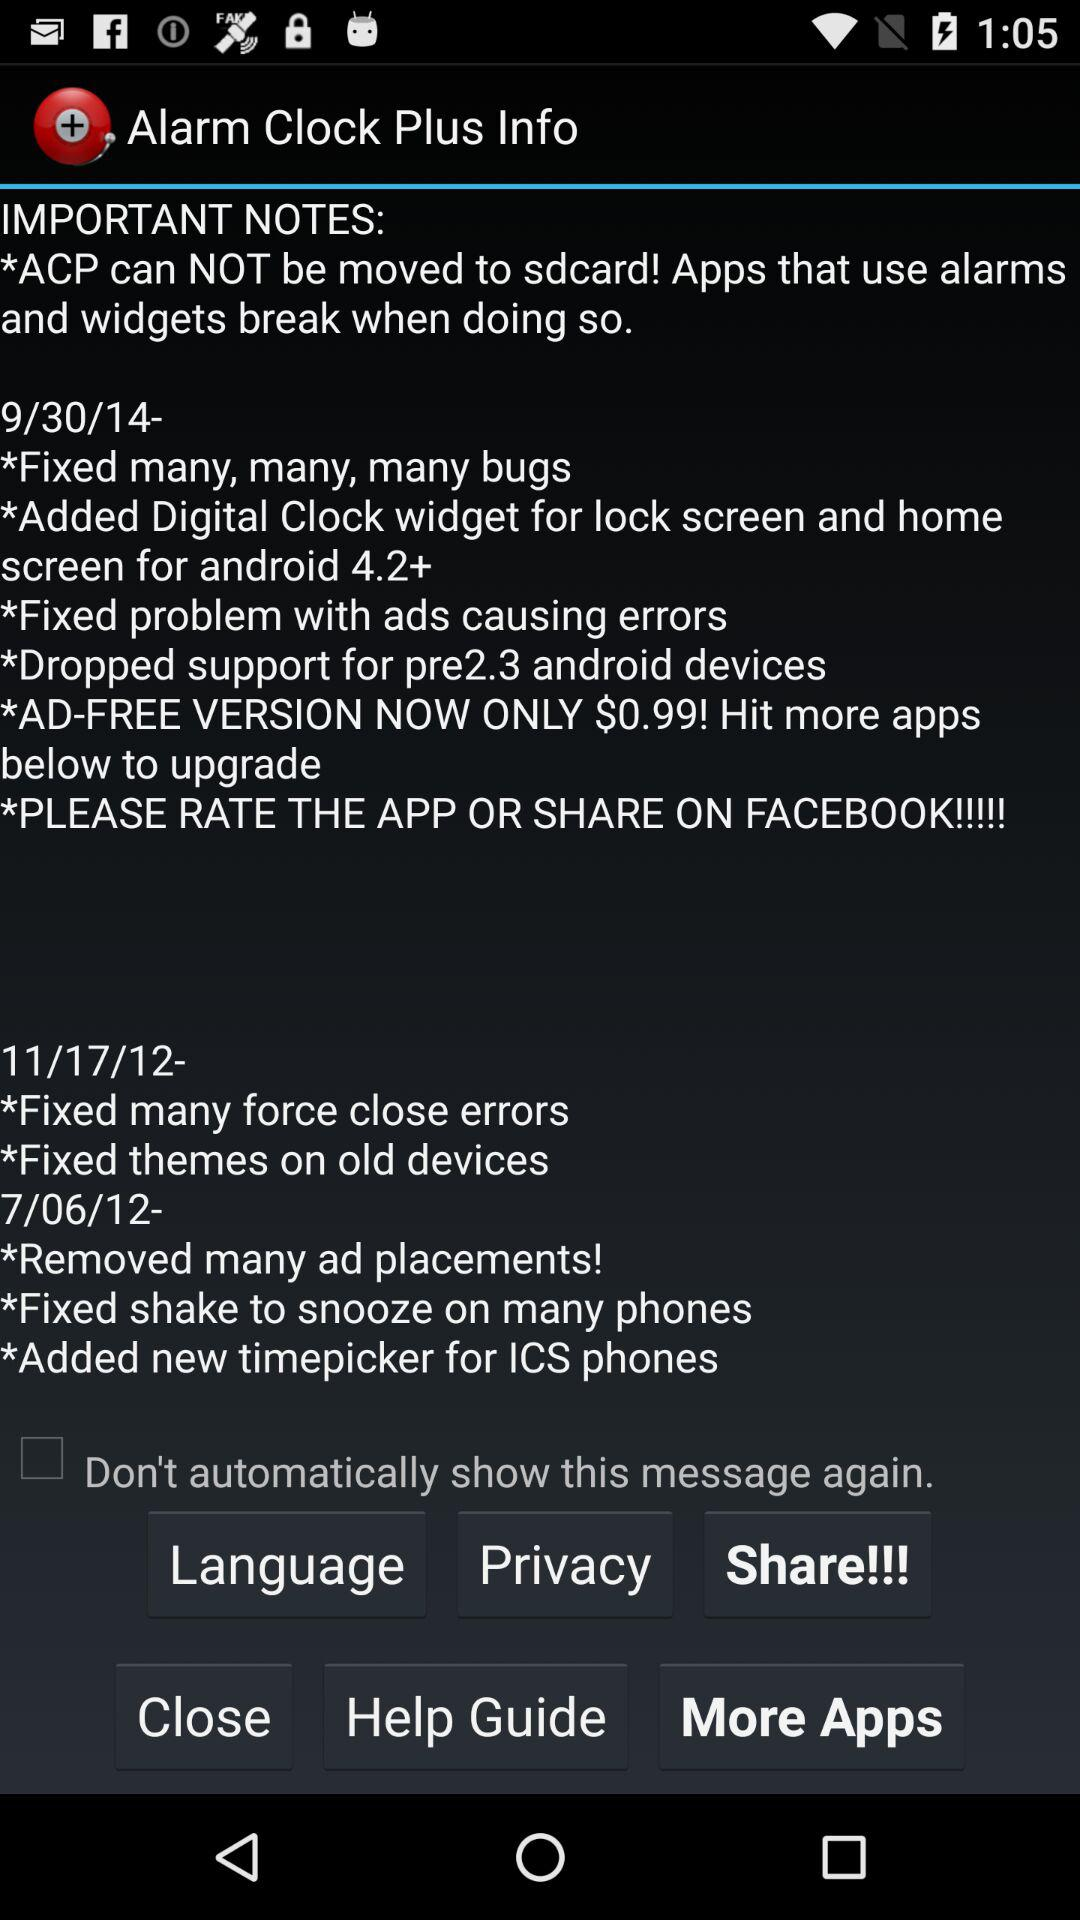What is the new update on 11/17/12? The new updates are "Fixed many force close errors" and "Fixed themes on old devices". 